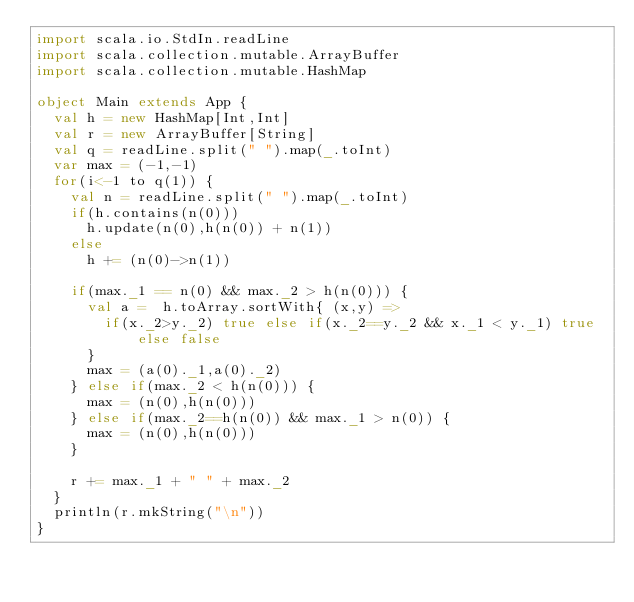Convert code to text. <code><loc_0><loc_0><loc_500><loc_500><_Scala_>import scala.io.StdIn.readLine
import scala.collection.mutable.ArrayBuffer
import scala.collection.mutable.HashMap

object Main extends App {
  val h = new HashMap[Int,Int]
  val r = new ArrayBuffer[String]
  val q = readLine.split(" ").map(_.toInt)
  var max = (-1,-1)
  for(i<-1 to q(1)) {
    val n = readLine.split(" ").map(_.toInt)
    if(h.contains(n(0)))
      h.update(n(0),h(n(0)) + n(1))
    else
      h += (n(0)->n(1))

    if(max._1 == n(0) && max._2 > h(n(0))) {
      val a =  h.toArray.sortWith{ (x,y) =>
        if(x._2>y._2) true else if(x._2==y._2 && x._1 < y._1) true else false
      }
      max = (a(0)._1,a(0)._2)
    } else if(max._2 < h(n(0))) {
      max = (n(0),h(n(0)))
    } else if(max._2==h(n(0)) && max._1 > n(0)) {
      max = (n(0),h(n(0)))
    }

    r += max._1 + " " + max._2
  }
  println(r.mkString("\n"))
}</code> 